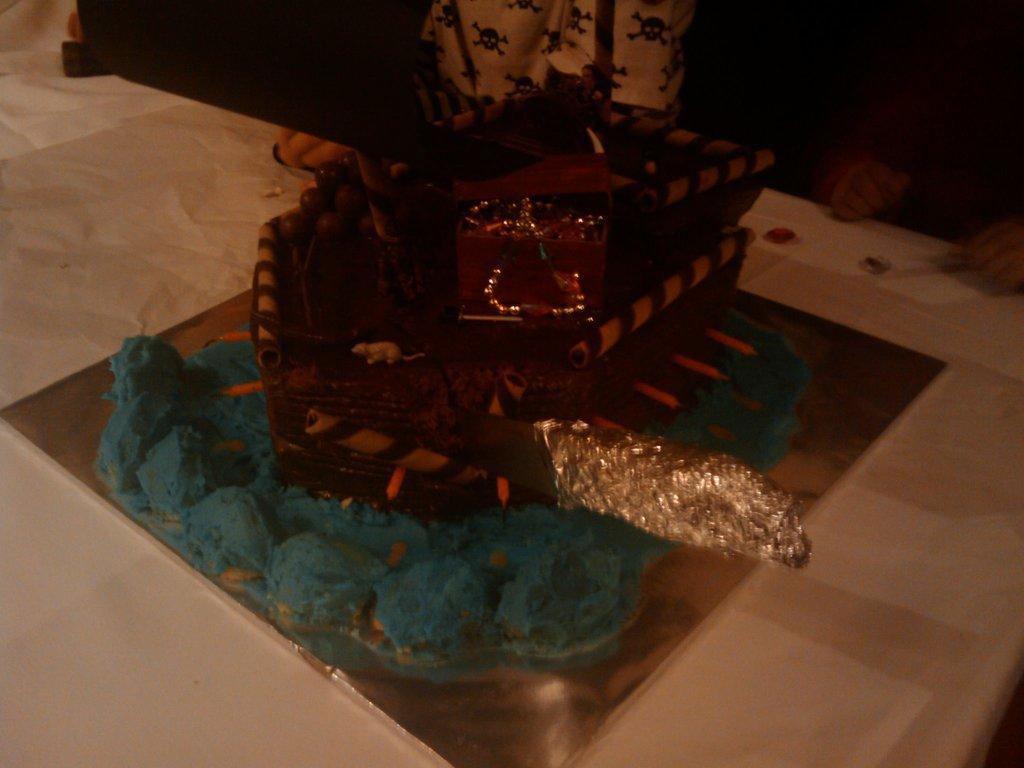In one or two sentences, can you explain what this image depicts? In this image we can see an object on the white color surface. At the top of the image, we can see two people. 